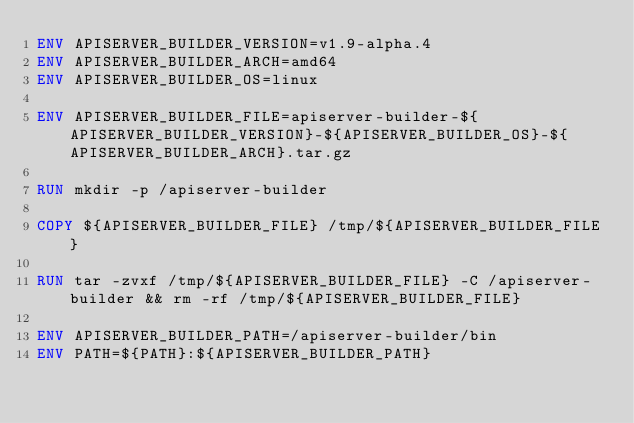<code> <loc_0><loc_0><loc_500><loc_500><_Dockerfile_>ENV APISERVER_BUILDER_VERSION=v1.9-alpha.4
ENV APISERVER_BUILDER_ARCH=amd64
ENV APISERVER_BUILDER_OS=linux

ENV APISERVER_BUILDER_FILE=apiserver-builder-${APISERVER_BUILDER_VERSION}-${APISERVER_BUILDER_OS}-${APISERVER_BUILDER_ARCH}.tar.gz

RUN mkdir -p /apiserver-builder

COPY ${APISERVER_BUILDER_FILE} /tmp/${APISERVER_BUILDER_FILE}

RUN tar -zvxf /tmp/${APISERVER_BUILDER_FILE} -C /apiserver-builder && rm -rf /tmp/${APISERVER_BUILDER_FILE}

ENV APISERVER_BUILDER_PATH=/apiserver-builder/bin
ENV PATH=${PATH}:${APISERVER_BUILDER_PATH}
</code> 